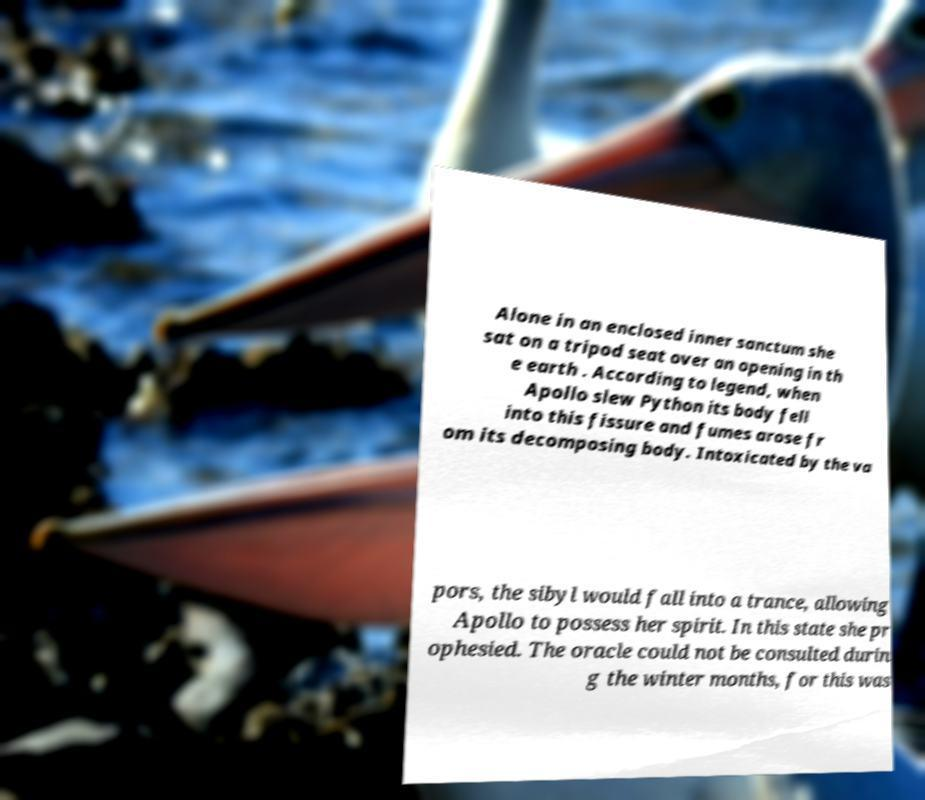Could you assist in decoding the text presented in this image and type it out clearly? Alone in an enclosed inner sanctum she sat on a tripod seat over an opening in th e earth . According to legend, when Apollo slew Python its body fell into this fissure and fumes arose fr om its decomposing body. Intoxicated by the va pors, the sibyl would fall into a trance, allowing Apollo to possess her spirit. In this state she pr ophesied. The oracle could not be consulted durin g the winter months, for this was 